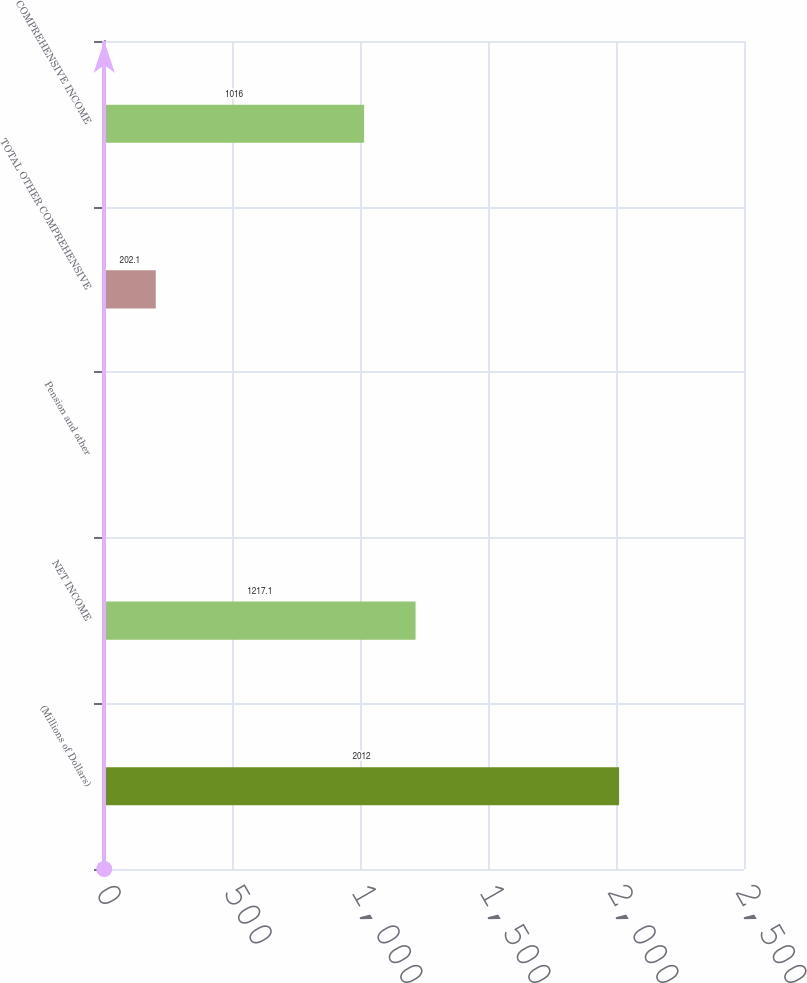Convert chart. <chart><loc_0><loc_0><loc_500><loc_500><bar_chart><fcel>(Millions of Dollars)<fcel>NET INCOME<fcel>Pension and other<fcel>TOTAL OTHER COMPREHENSIVE<fcel>COMPREHENSIVE INCOME<nl><fcel>2012<fcel>1217.1<fcel>1<fcel>202.1<fcel>1016<nl></chart> 